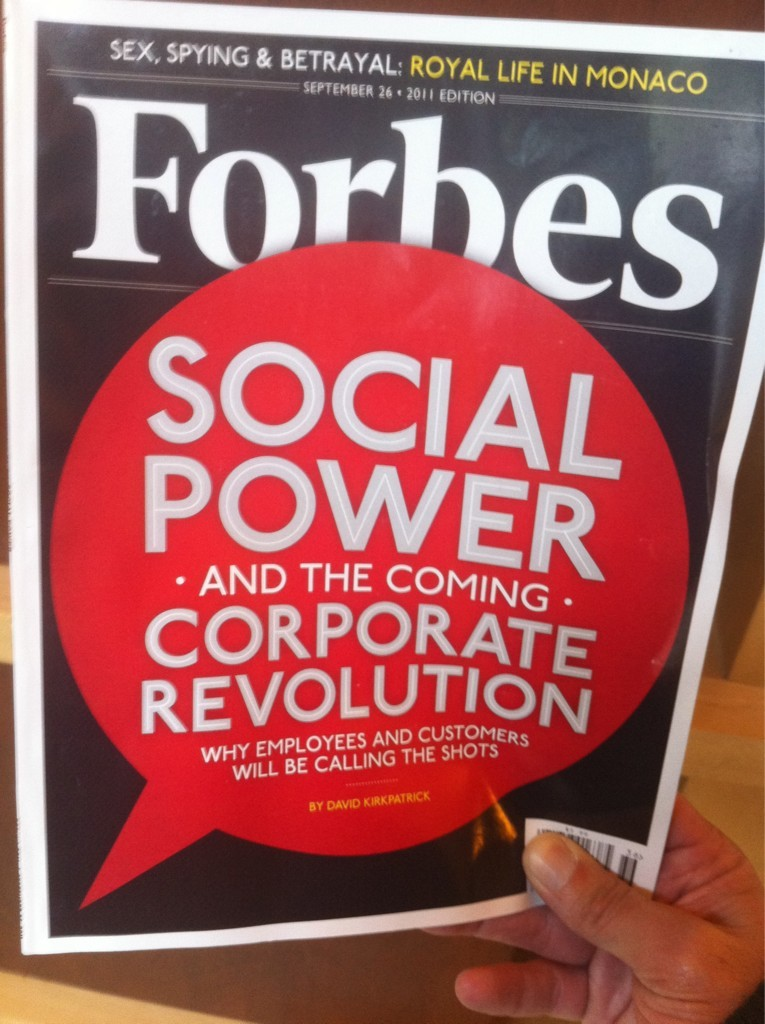Can you tell more about the types of articles typically featured in this edition of Forbes? This edition of Forbes seems to delve into issues at the intersection of power, personal affairs, and social change. The cover hints at articles ranging from high-stake topics in corporate settings driven by social media influence, to sensational stories like that of Monaco's royal family, showcasing a blend of business analysis and investigative journalism into personal and public lives of influential figures. 